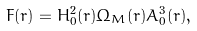<formula> <loc_0><loc_0><loc_500><loc_500>F ( r ) = H _ { 0 } ^ { 2 } ( r ) \Omega _ { M } ( r ) A _ { 0 } ^ { 3 } ( r ) ,</formula> 